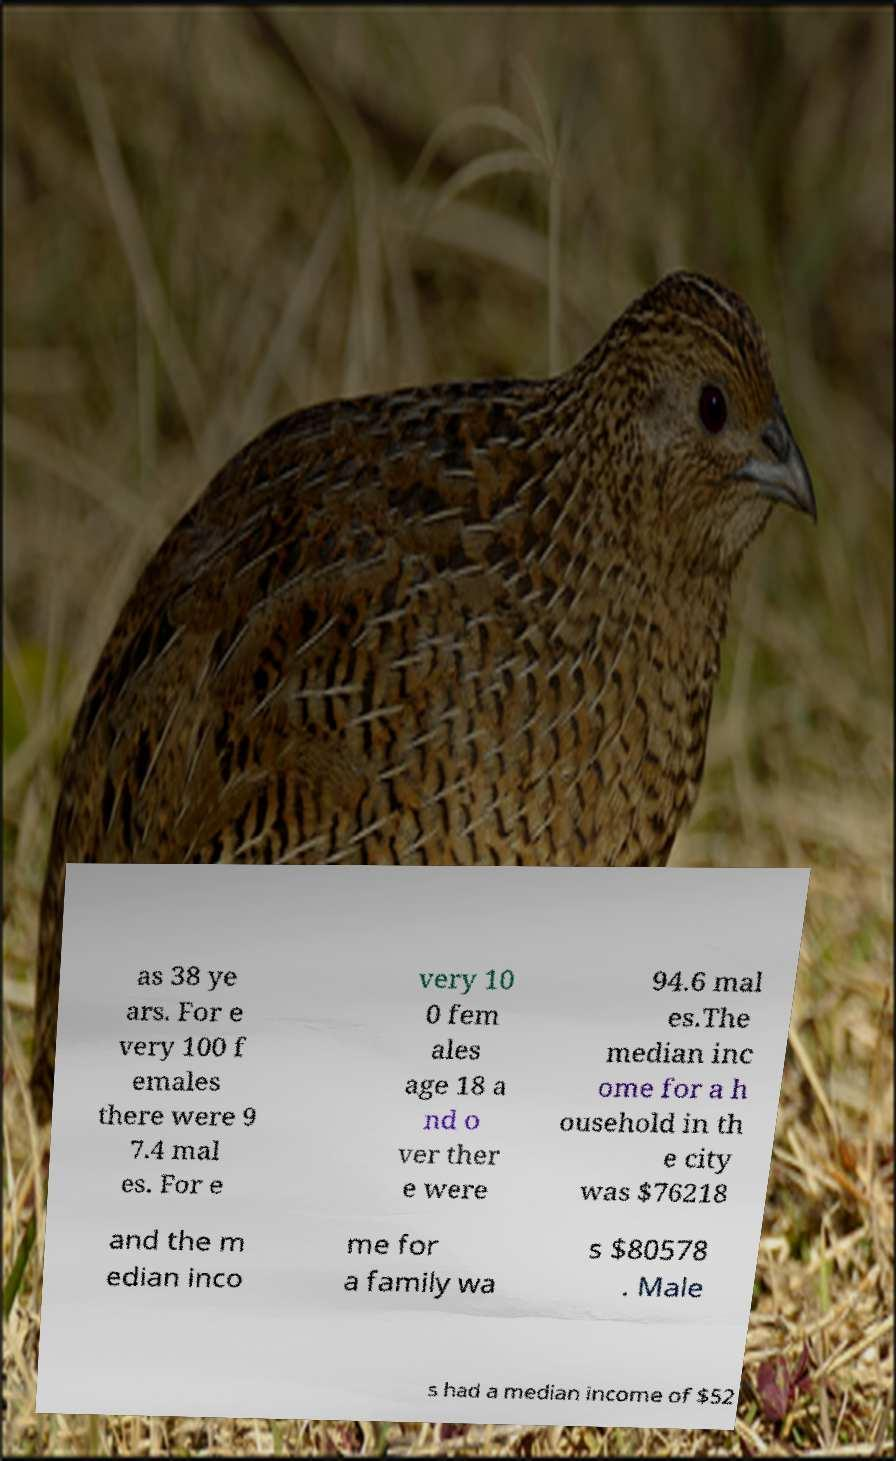What messages or text are displayed in this image? I need them in a readable, typed format. as 38 ye ars. For e very 100 f emales there were 9 7.4 mal es. For e very 10 0 fem ales age 18 a nd o ver ther e were 94.6 mal es.The median inc ome for a h ousehold in th e city was $76218 and the m edian inco me for a family wa s $80578 . Male s had a median income of $52 